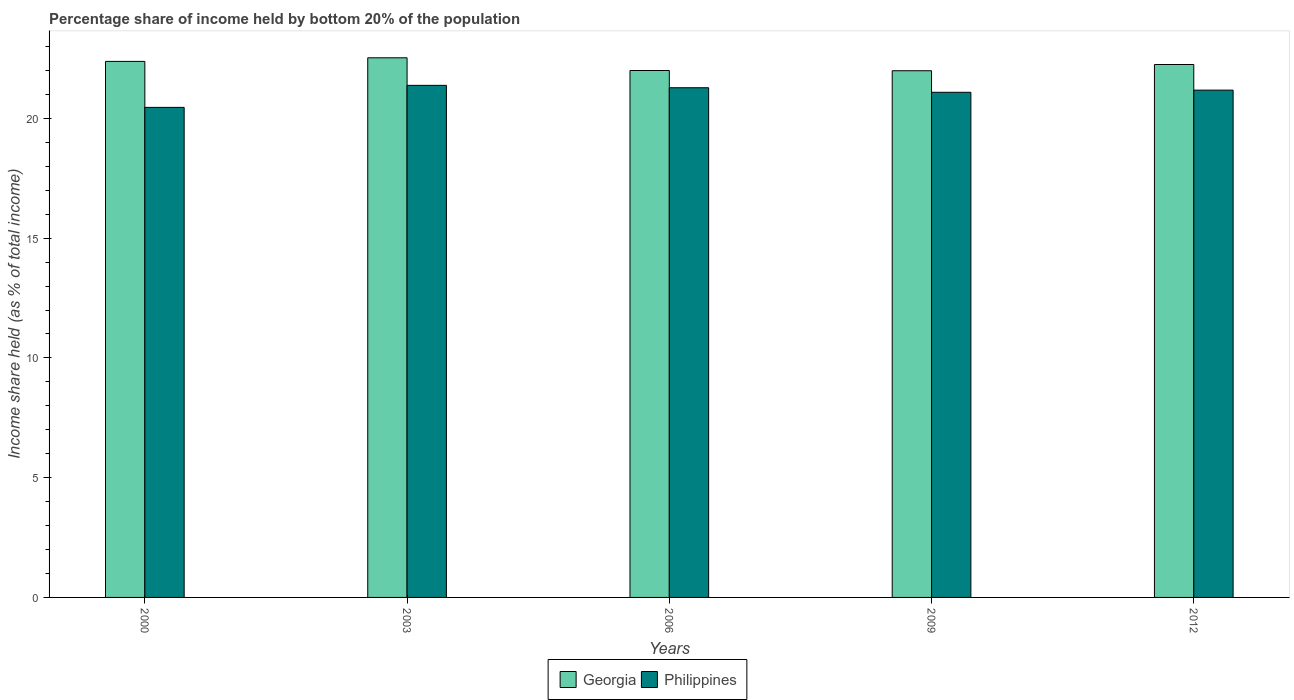How many different coloured bars are there?
Make the answer very short. 2. How many groups of bars are there?
Provide a short and direct response. 5. Are the number of bars per tick equal to the number of legend labels?
Provide a short and direct response. Yes. How many bars are there on the 4th tick from the right?
Provide a succinct answer. 2. What is the share of income held by bottom 20% of the population in Philippines in 2003?
Provide a short and direct response. 21.38. Across all years, what is the maximum share of income held by bottom 20% of the population in Philippines?
Offer a terse response. 21.38. Across all years, what is the minimum share of income held by bottom 20% of the population in Georgia?
Provide a short and direct response. 21.99. In which year was the share of income held by bottom 20% of the population in Georgia maximum?
Offer a very short reply. 2003. In which year was the share of income held by bottom 20% of the population in Philippines minimum?
Offer a very short reply. 2000. What is the total share of income held by bottom 20% of the population in Philippines in the graph?
Your response must be concise. 105.39. What is the difference between the share of income held by bottom 20% of the population in Georgia in 2000 and that in 2003?
Provide a short and direct response. -0.15. What is the difference between the share of income held by bottom 20% of the population in Philippines in 2003 and the share of income held by bottom 20% of the population in Georgia in 2009?
Keep it short and to the point. -0.61. What is the average share of income held by bottom 20% of the population in Philippines per year?
Provide a succinct answer. 21.08. In the year 2012, what is the difference between the share of income held by bottom 20% of the population in Philippines and share of income held by bottom 20% of the population in Georgia?
Make the answer very short. -1.07. In how many years, is the share of income held by bottom 20% of the population in Philippines greater than 8 %?
Your answer should be compact. 5. What is the ratio of the share of income held by bottom 20% of the population in Philippines in 2000 to that in 2003?
Provide a succinct answer. 0.96. Is the share of income held by bottom 20% of the population in Georgia in 2000 less than that in 2012?
Keep it short and to the point. No. Is the difference between the share of income held by bottom 20% of the population in Philippines in 2000 and 2006 greater than the difference between the share of income held by bottom 20% of the population in Georgia in 2000 and 2006?
Provide a short and direct response. No. What is the difference between the highest and the second highest share of income held by bottom 20% of the population in Georgia?
Offer a very short reply. 0.15. What is the difference between the highest and the lowest share of income held by bottom 20% of the population in Philippines?
Make the answer very short. 0.92. What does the 1st bar from the left in 2003 represents?
Offer a terse response. Georgia. What does the 2nd bar from the right in 2000 represents?
Provide a succinct answer. Georgia. How many bars are there?
Provide a succinct answer. 10. Are all the bars in the graph horizontal?
Your response must be concise. No. How many years are there in the graph?
Your answer should be compact. 5. What is the difference between two consecutive major ticks on the Y-axis?
Provide a short and direct response. 5. How are the legend labels stacked?
Provide a succinct answer. Horizontal. What is the title of the graph?
Your answer should be compact. Percentage share of income held by bottom 20% of the population. What is the label or title of the X-axis?
Your response must be concise. Years. What is the label or title of the Y-axis?
Keep it short and to the point. Income share held (as % of total income). What is the Income share held (as % of total income) of Georgia in 2000?
Make the answer very short. 22.38. What is the Income share held (as % of total income) of Philippines in 2000?
Your answer should be very brief. 20.46. What is the Income share held (as % of total income) in Georgia in 2003?
Your answer should be very brief. 22.53. What is the Income share held (as % of total income) in Philippines in 2003?
Keep it short and to the point. 21.38. What is the Income share held (as % of total income) of Georgia in 2006?
Provide a succinct answer. 22. What is the Income share held (as % of total income) in Philippines in 2006?
Ensure brevity in your answer.  21.28. What is the Income share held (as % of total income) in Georgia in 2009?
Make the answer very short. 21.99. What is the Income share held (as % of total income) in Philippines in 2009?
Offer a terse response. 21.09. What is the Income share held (as % of total income) in Georgia in 2012?
Your answer should be compact. 22.25. What is the Income share held (as % of total income) of Philippines in 2012?
Your response must be concise. 21.18. Across all years, what is the maximum Income share held (as % of total income) of Georgia?
Make the answer very short. 22.53. Across all years, what is the maximum Income share held (as % of total income) in Philippines?
Your answer should be compact. 21.38. Across all years, what is the minimum Income share held (as % of total income) of Georgia?
Keep it short and to the point. 21.99. Across all years, what is the minimum Income share held (as % of total income) of Philippines?
Ensure brevity in your answer.  20.46. What is the total Income share held (as % of total income) in Georgia in the graph?
Offer a terse response. 111.15. What is the total Income share held (as % of total income) in Philippines in the graph?
Your response must be concise. 105.39. What is the difference between the Income share held (as % of total income) of Philippines in 2000 and that in 2003?
Ensure brevity in your answer.  -0.92. What is the difference between the Income share held (as % of total income) of Georgia in 2000 and that in 2006?
Give a very brief answer. 0.38. What is the difference between the Income share held (as % of total income) in Philippines in 2000 and that in 2006?
Your answer should be very brief. -0.82. What is the difference between the Income share held (as % of total income) in Georgia in 2000 and that in 2009?
Give a very brief answer. 0.39. What is the difference between the Income share held (as % of total income) of Philippines in 2000 and that in 2009?
Your response must be concise. -0.63. What is the difference between the Income share held (as % of total income) of Georgia in 2000 and that in 2012?
Your answer should be very brief. 0.13. What is the difference between the Income share held (as % of total income) of Philippines in 2000 and that in 2012?
Make the answer very short. -0.72. What is the difference between the Income share held (as % of total income) of Georgia in 2003 and that in 2006?
Your answer should be compact. 0.53. What is the difference between the Income share held (as % of total income) in Georgia in 2003 and that in 2009?
Your answer should be compact. 0.54. What is the difference between the Income share held (as % of total income) of Philippines in 2003 and that in 2009?
Make the answer very short. 0.29. What is the difference between the Income share held (as % of total income) of Georgia in 2003 and that in 2012?
Give a very brief answer. 0.28. What is the difference between the Income share held (as % of total income) in Philippines in 2003 and that in 2012?
Ensure brevity in your answer.  0.2. What is the difference between the Income share held (as % of total income) of Georgia in 2006 and that in 2009?
Offer a terse response. 0.01. What is the difference between the Income share held (as % of total income) of Philippines in 2006 and that in 2009?
Keep it short and to the point. 0.19. What is the difference between the Income share held (as % of total income) in Georgia in 2006 and that in 2012?
Your answer should be very brief. -0.25. What is the difference between the Income share held (as % of total income) of Georgia in 2009 and that in 2012?
Provide a succinct answer. -0.26. What is the difference between the Income share held (as % of total income) in Philippines in 2009 and that in 2012?
Offer a very short reply. -0.09. What is the difference between the Income share held (as % of total income) of Georgia in 2000 and the Income share held (as % of total income) of Philippines in 2006?
Keep it short and to the point. 1.1. What is the difference between the Income share held (as % of total income) in Georgia in 2000 and the Income share held (as % of total income) in Philippines in 2009?
Your response must be concise. 1.29. What is the difference between the Income share held (as % of total income) of Georgia in 2000 and the Income share held (as % of total income) of Philippines in 2012?
Make the answer very short. 1.2. What is the difference between the Income share held (as % of total income) of Georgia in 2003 and the Income share held (as % of total income) of Philippines in 2006?
Your response must be concise. 1.25. What is the difference between the Income share held (as % of total income) of Georgia in 2003 and the Income share held (as % of total income) of Philippines in 2009?
Your answer should be very brief. 1.44. What is the difference between the Income share held (as % of total income) of Georgia in 2003 and the Income share held (as % of total income) of Philippines in 2012?
Keep it short and to the point. 1.35. What is the difference between the Income share held (as % of total income) of Georgia in 2006 and the Income share held (as % of total income) of Philippines in 2009?
Ensure brevity in your answer.  0.91. What is the difference between the Income share held (as % of total income) in Georgia in 2006 and the Income share held (as % of total income) in Philippines in 2012?
Your answer should be very brief. 0.82. What is the difference between the Income share held (as % of total income) in Georgia in 2009 and the Income share held (as % of total income) in Philippines in 2012?
Provide a short and direct response. 0.81. What is the average Income share held (as % of total income) of Georgia per year?
Your answer should be very brief. 22.23. What is the average Income share held (as % of total income) of Philippines per year?
Offer a terse response. 21.08. In the year 2000, what is the difference between the Income share held (as % of total income) of Georgia and Income share held (as % of total income) of Philippines?
Provide a short and direct response. 1.92. In the year 2003, what is the difference between the Income share held (as % of total income) in Georgia and Income share held (as % of total income) in Philippines?
Offer a very short reply. 1.15. In the year 2006, what is the difference between the Income share held (as % of total income) in Georgia and Income share held (as % of total income) in Philippines?
Your answer should be compact. 0.72. In the year 2009, what is the difference between the Income share held (as % of total income) of Georgia and Income share held (as % of total income) of Philippines?
Your response must be concise. 0.9. In the year 2012, what is the difference between the Income share held (as % of total income) in Georgia and Income share held (as % of total income) in Philippines?
Provide a short and direct response. 1.07. What is the ratio of the Income share held (as % of total income) of Philippines in 2000 to that in 2003?
Provide a succinct answer. 0.96. What is the ratio of the Income share held (as % of total income) of Georgia in 2000 to that in 2006?
Your response must be concise. 1.02. What is the ratio of the Income share held (as % of total income) in Philippines in 2000 to that in 2006?
Your response must be concise. 0.96. What is the ratio of the Income share held (as % of total income) in Georgia in 2000 to that in 2009?
Your answer should be very brief. 1.02. What is the ratio of the Income share held (as % of total income) in Philippines in 2000 to that in 2009?
Your answer should be very brief. 0.97. What is the ratio of the Income share held (as % of total income) of Philippines in 2000 to that in 2012?
Keep it short and to the point. 0.97. What is the ratio of the Income share held (as % of total income) of Georgia in 2003 to that in 2006?
Your answer should be compact. 1.02. What is the ratio of the Income share held (as % of total income) of Philippines in 2003 to that in 2006?
Give a very brief answer. 1. What is the ratio of the Income share held (as % of total income) of Georgia in 2003 to that in 2009?
Your response must be concise. 1.02. What is the ratio of the Income share held (as % of total income) of Philippines in 2003 to that in 2009?
Offer a very short reply. 1.01. What is the ratio of the Income share held (as % of total income) in Georgia in 2003 to that in 2012?
Offer a terse response. 1.01. What is the ratio of the Income share held (as % of total income) in Philippines in 2003 to that in 2012?
Keep it short and to the point. 1.01. What is the ratio of the Income share held (as % of total income) of Georgia in 2006 to that in 2009?
Keep it short and to the point. 1. What is the ratio of the Income share held (as % of total income) in Philippines in 2006 to that in 2012?
Give a very brief answer. 1. What is the ratio of the Income share held (as % of total income) of Georgia in 2009 to that in 2012?
Give a very brief answer. 0.99. What is the difference between the highest and the second highest Income share held (as % of total income) of Georgia?
Keep it short and to the point. 0.15. What is the difference between the highest and the lowest Income share held (as % of total income) of Georgia?
Your answer should be compact. 0.54. What is the difference between the highest and the lowest Income share held (as % of total income) of Philippines?
Offer a very short reply. 0.92. 